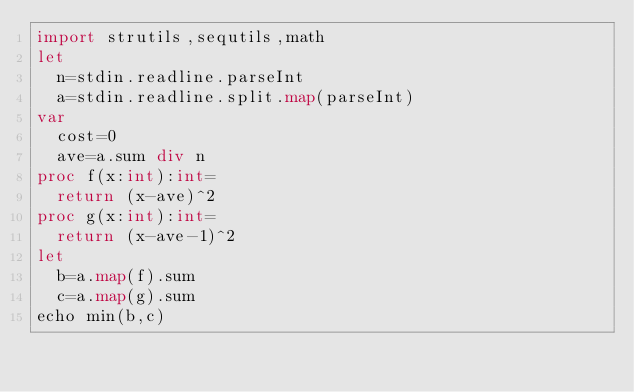<code> <loc_0><loc_0><loc_500><loc_500><_Nim_>import strutils,sequtils,math
let
  n=stdin.readline.parseInt
  a=stdin.readline.split.map(parseInt)
var
  cost=0
  ave=a.sum div n
proc f(x:int):int=
  return (x-ave)^2
proc g(x:int):int=
  return (x-ave-1)^2
let
  b=a.map(f).sum
  c=a.map(g).sum
echo min(b,c)</code> 